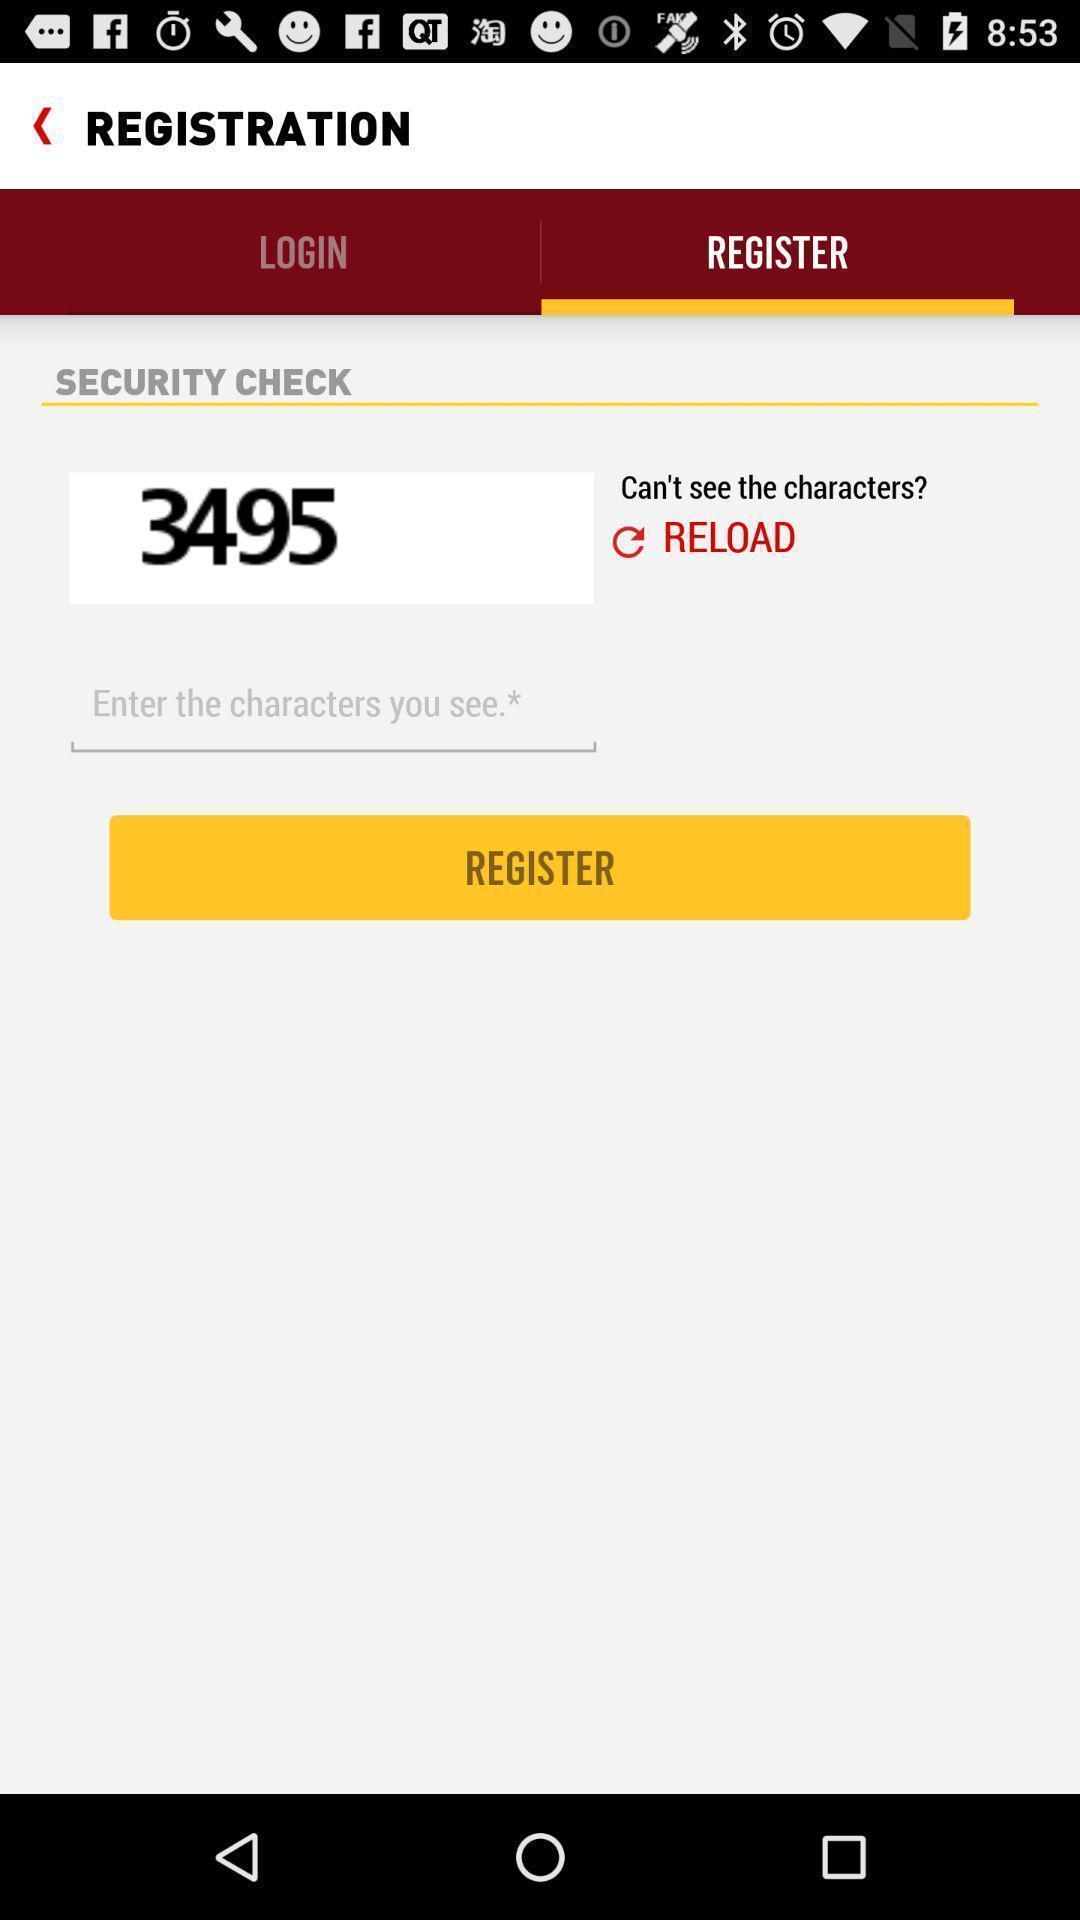Please provide a description for this image. Screen displaying the register page. 